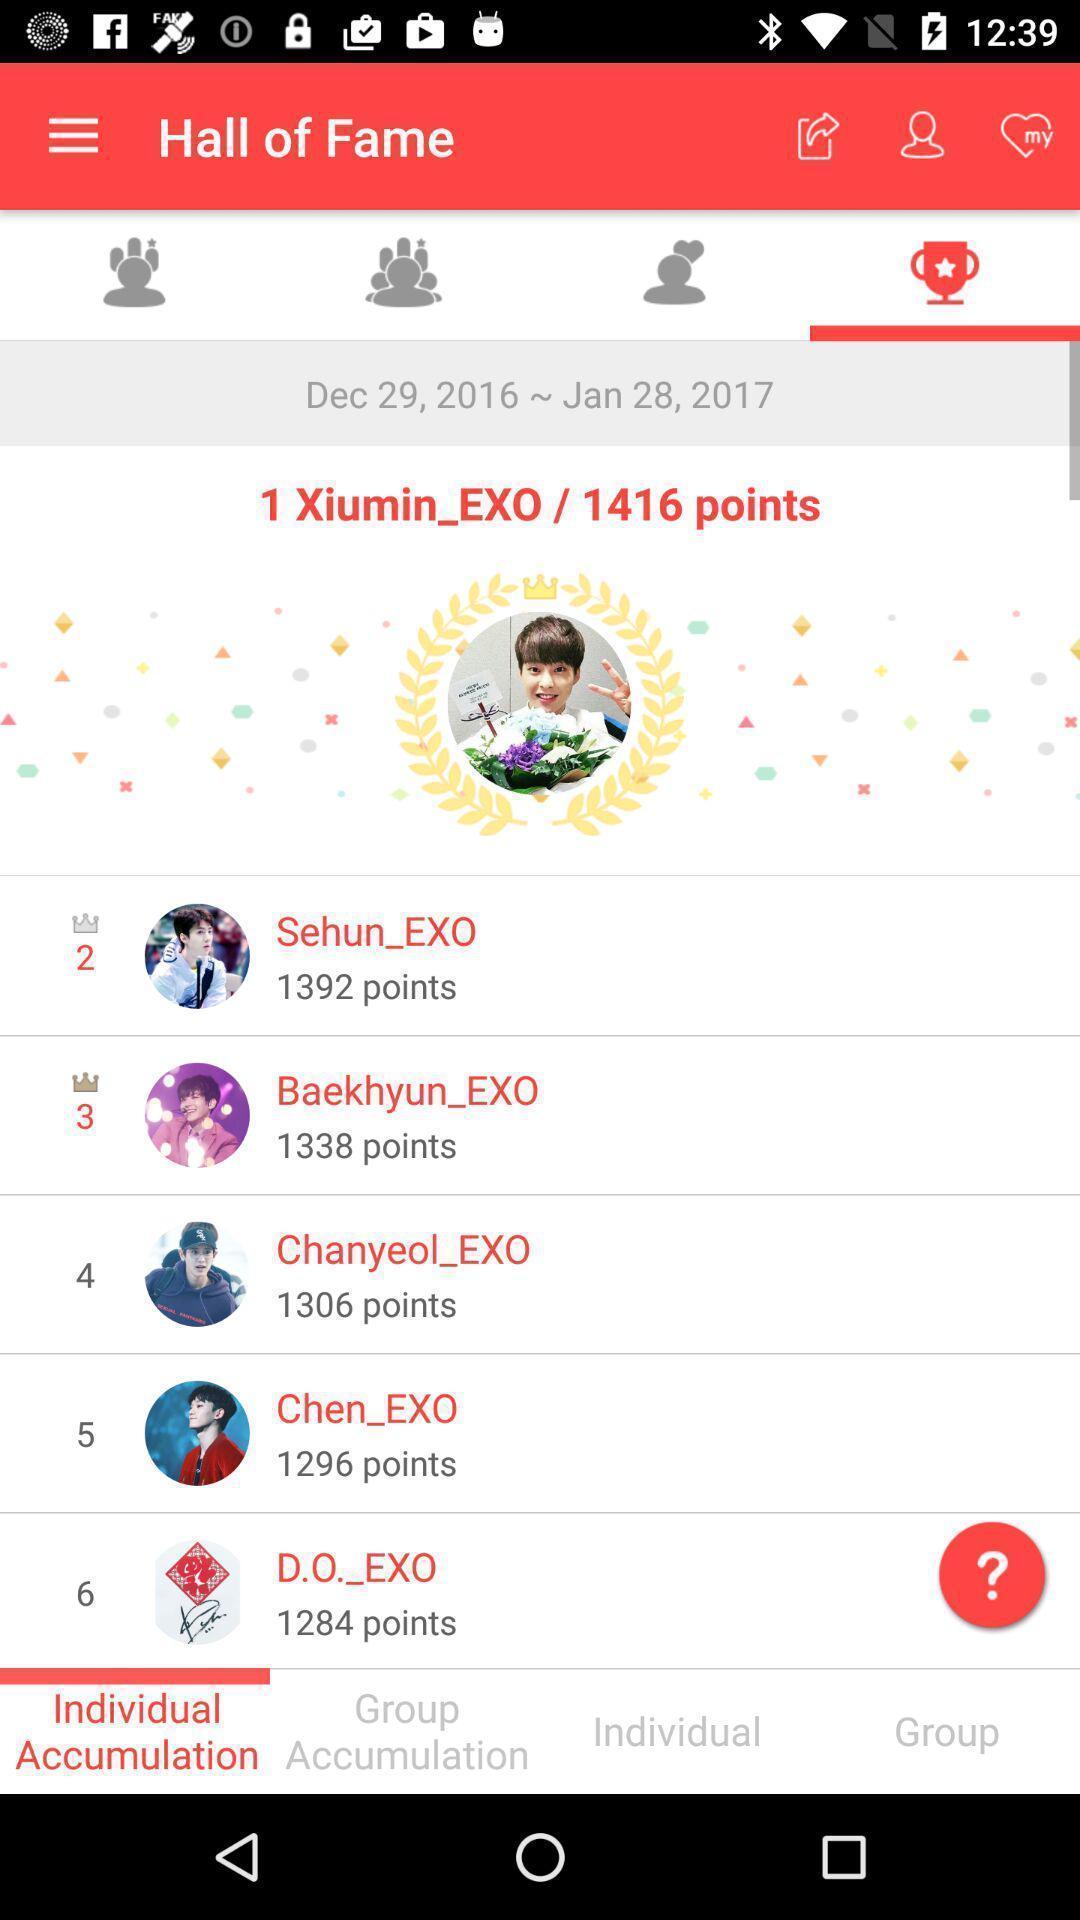Provide a detailed account of this screenshot. Screen displaying hall of fame page. 